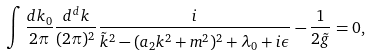<formula> <loc_0><loc_0><loc_500><loc_500>\int \frac { d k _ { 0 } } { 2 \pi } \frac { d ^ { d } k } { ( 2 \pi ) ^ { 2 } } \frac { i } { \tilde { k } ^ { 2 } - ( a _ { 2 } { k } ^ { 2 } + m ^ { 2 } ) ^ { 2 } + \lambda _ { 0 } + i \epsilon } - \frac { 1 } { 2 \tilde { g } } = 0 ,</formula> 